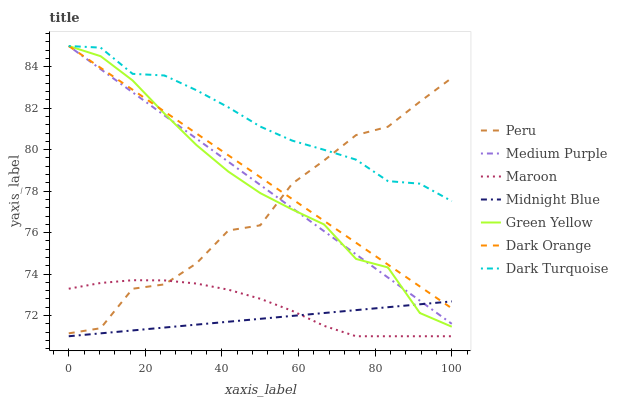Does Midnight Blue have the minimum area under the curve?
Answer yes or no. Yes. Does Dark Turquoise have the maximum area under the curve?
Answer yes or no. Yes. Does Dark Turquoise have the minimum area under the curve?
Answer yes or no. No. Does Midnight Blue have the maximum area under the curve?
Answer yes or no. No. Is Dark Orange the smoothest?
Answer yes or no. Yes. Is Peru the roughest?
Answer yes or no. Yes. Is Midnight Blue the smoothest?
Answer yes or no. No. Is Midnight Blue the roughest?
Answer yes or no. No. Does Dark Turquoise have the lowest value?
Answer yes or no. No. Does Midnight Blue have the highest value?
Answer yes or no. No. Is Midnight Blue less than Dark Turquoise?
Answer yes or no. Yes. Is Medium Purple greater than Maroon?
Answer yes or no. Yes. Does Midnight Blue intersect Dark Turquoise?
Answer yes or no. No. 